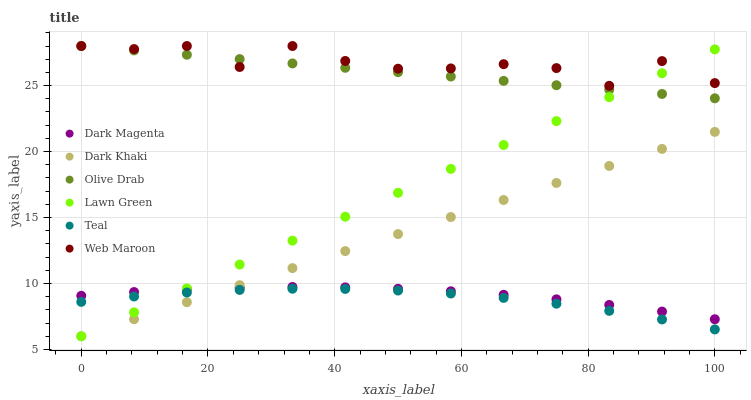Does Teal have the minimum area under the curve?
Answer yes or no. Yes. Does Web Maroon have the maximum area under the curve?
Answer yes or no. Yes. Does Dark Magenta have the minimum area under the curve?
Answer yes or no. No. Does Dark Magenta have the maximum area under the curve?
Answer yes or no. No. Is Dark Khaki the smoothest?
Answer yes or no. Yes. Is Web Maroon the roughest?
Answer yes or no. Yes. Is Dark Magenta the smoothest?
Answer yes or no. No. Is Dark Magenta the roughest?
Answer yes or no. No. Does Lawn Green have the lowest value?
Answer yes or no. Yes. Does Dark Magenta have the lowest value?
Answer yes or no. No. Does Olive Drab have the highest value?
Answer yes or no. Yes. Does Dark Magenta have the highest value?
Answer yes or no. No. Is Dark Magenta less than Olive Drab?
Answer yes or no. Yes. Is Web Maroon greater than Teal?
Answer yes or no. Yes. Does Olive Drab intersect Web Maroon?
Answer yes or no. Yes. Is Olive Drab less than Web Maroon?
Answer yes or no. No. Is Olive Drab greater than Web Maroon?
Answer yes or no. No. Does Dark Magenta intersect Olive Drab?
Answer yes or no. No. 